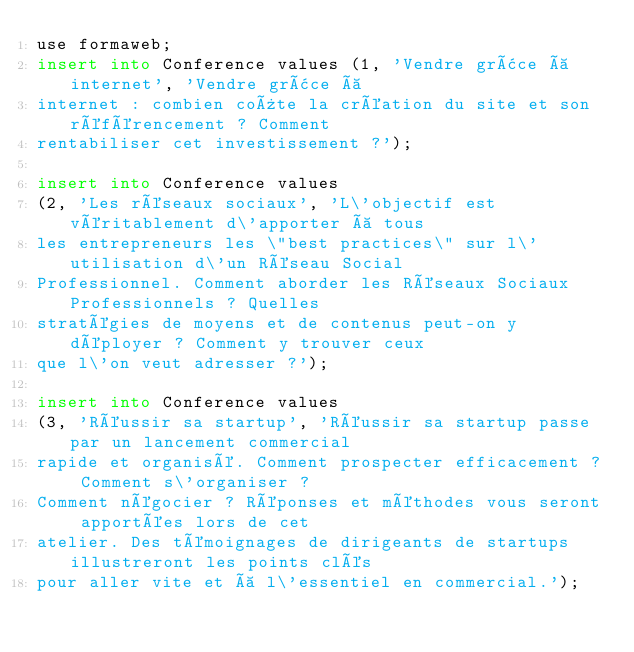<code> <loc_0><loc_0><loc_500><loc_500><_SQL_>use formaweb;
insert into Conference values (1, 'Vendre grâce à internet', 'Vendre grâce à
internet : combien coûte la création du site et son référencement ? Comment
rentabiliser cet investissement ?');

insert into Conference values
(2, 'Les réseaux sociaux', 'L\'objectif est véritablement d\'apporter à tous
les entrepreneurs les \"best practices\" sur l\'utilisation d\'un Réseau Social
Professionnel. Comment aborder les Réseaux Sociaux Professionnels ? Quelles
stratégies de moyens et de contenus peut-on y déployer ? Comment y trouver ceux
que l\'on veut adresser ?');

insert into Conference values
(3, 'Réussir sa startup', 'Réussir sa startup passe par un lancement commercial
rapide et organisé. Comment prospecter efficacement ? Comment s\'organiser ?
Comment négocier ? Réponses et méthodes vous seront apportées lors de cet
atelier. Des témoignages de dirigeants de startups illustreront les points clés
pour aller vite et à l\'essentiel en commercial.');</code> 